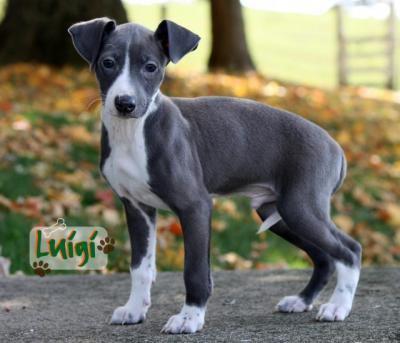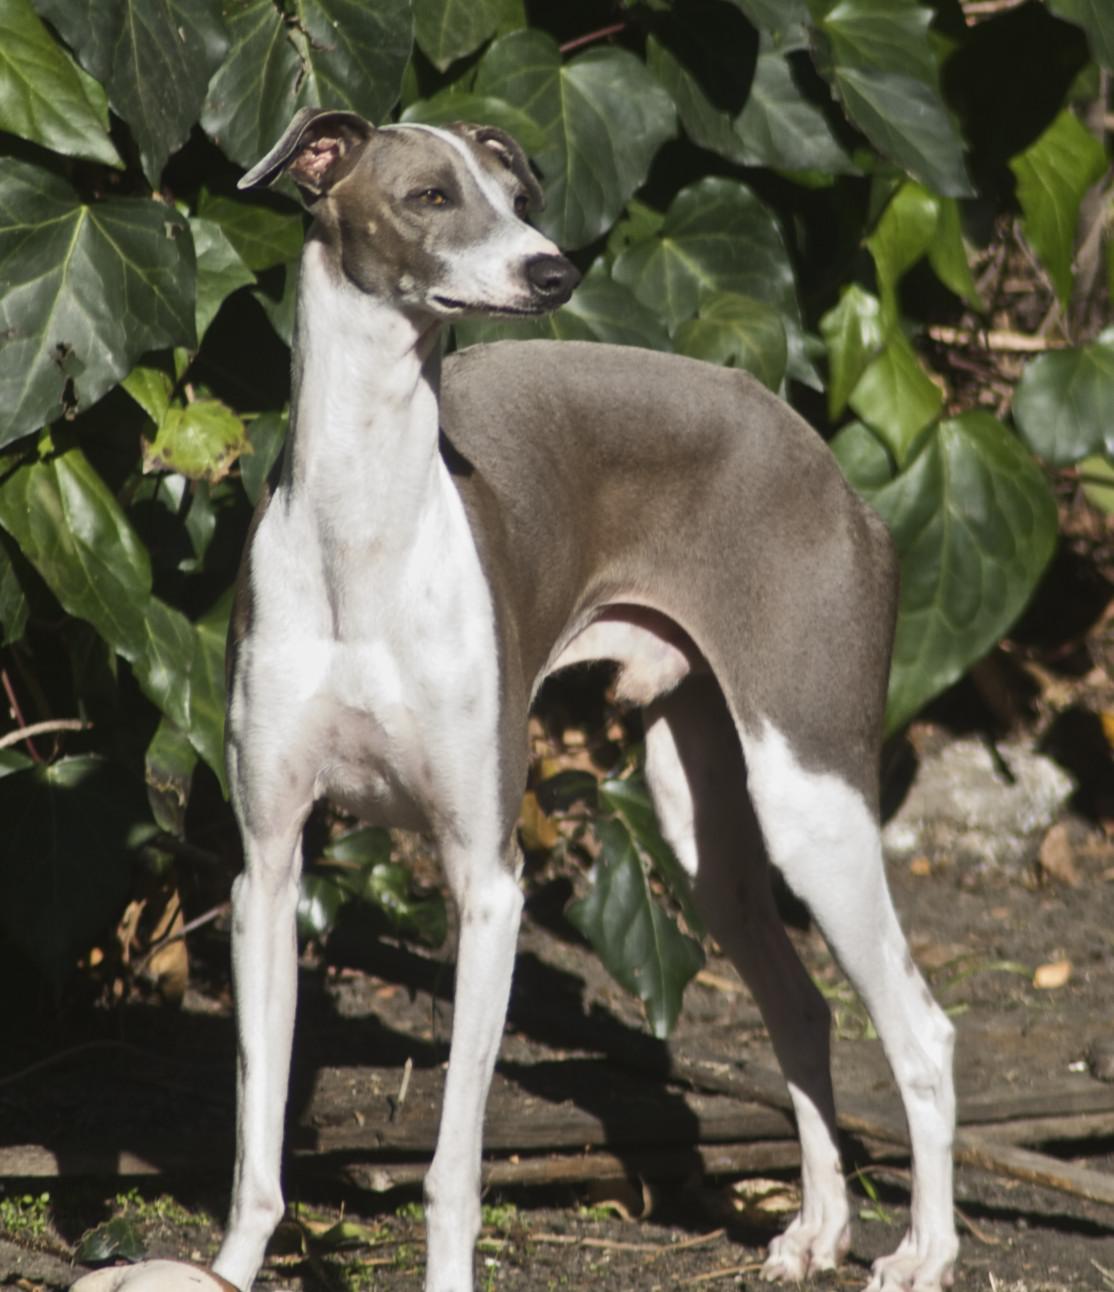The first image is the image on the left, the second image is the image on the right. Evaluate the accuracy of this statement regarding the images: "At least one of the dogs is outside on the grass.". Is it true? Answer yes or no. No. The first image is the image on the left, the second image is the image on the right. Evaluate the accuracy of this statement regarding the images: "An image shows a standing dog with its white tail tip curled under and between its legs.". Is it true? Answer yes or no. Yes. 